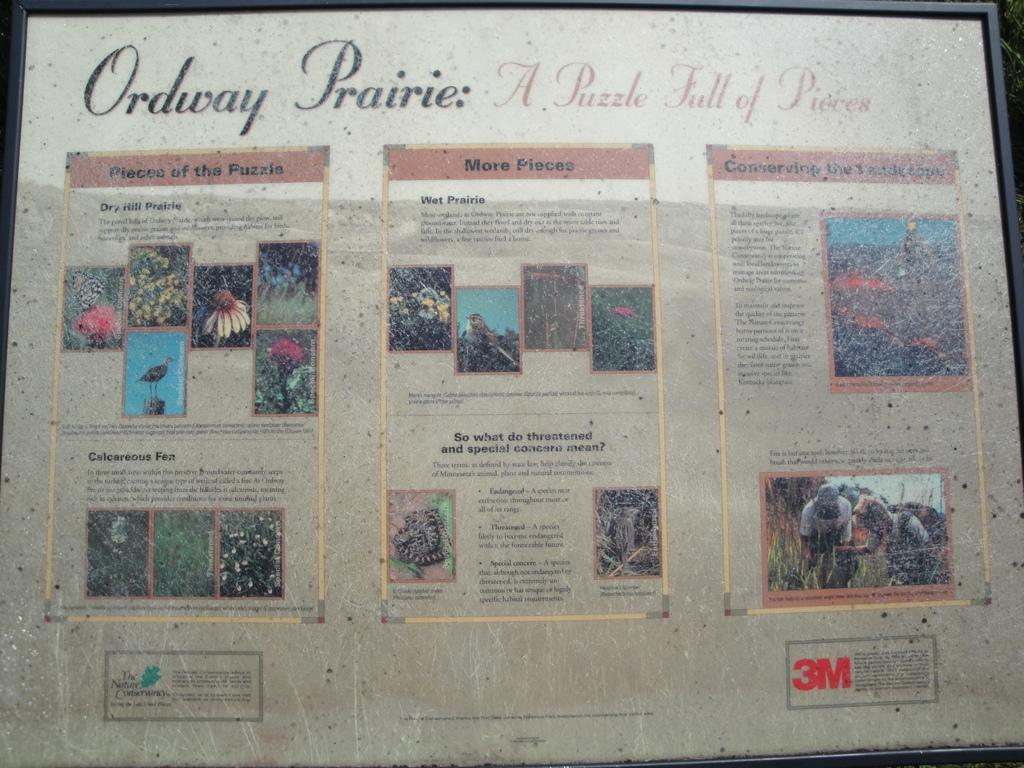<image>
Create a compact narrative representing the image presented. Ordway Prairie newspaper  A puzzle full of pieces 